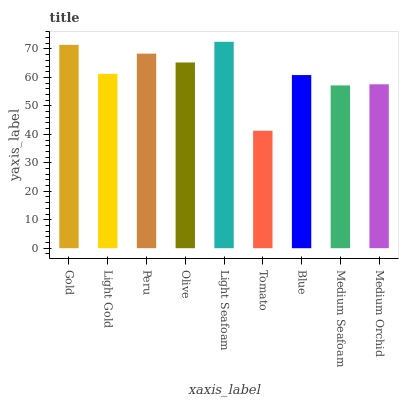Is Tomato the minimum?
Answer yes or no. Yes. Is Light Seafoam the maximum?
Answer yes or no. Yes. Is Light Gold the minimum?
Answer yes or no. No. Is Light Gold the maximum?
Answer yes or no. No. Is Gold greater than Light Gold?
Answer yes or no. Yes. Is Light Gold less than Gold?
Answer yes or no. Yes. Is Light Gold greater than Gold?
Answer yes or no. No. Is Gold less than Light Gold?
Answer yes or no. No. Is Light Gold the high median?
Answer yes or no. Yes. Is Light Gold the low median?
Answer yes or no. Yes. Is Medium Orchid the high median?
Answer yes or no. No. Is Gold the low median?
Answer yes or no. No. 